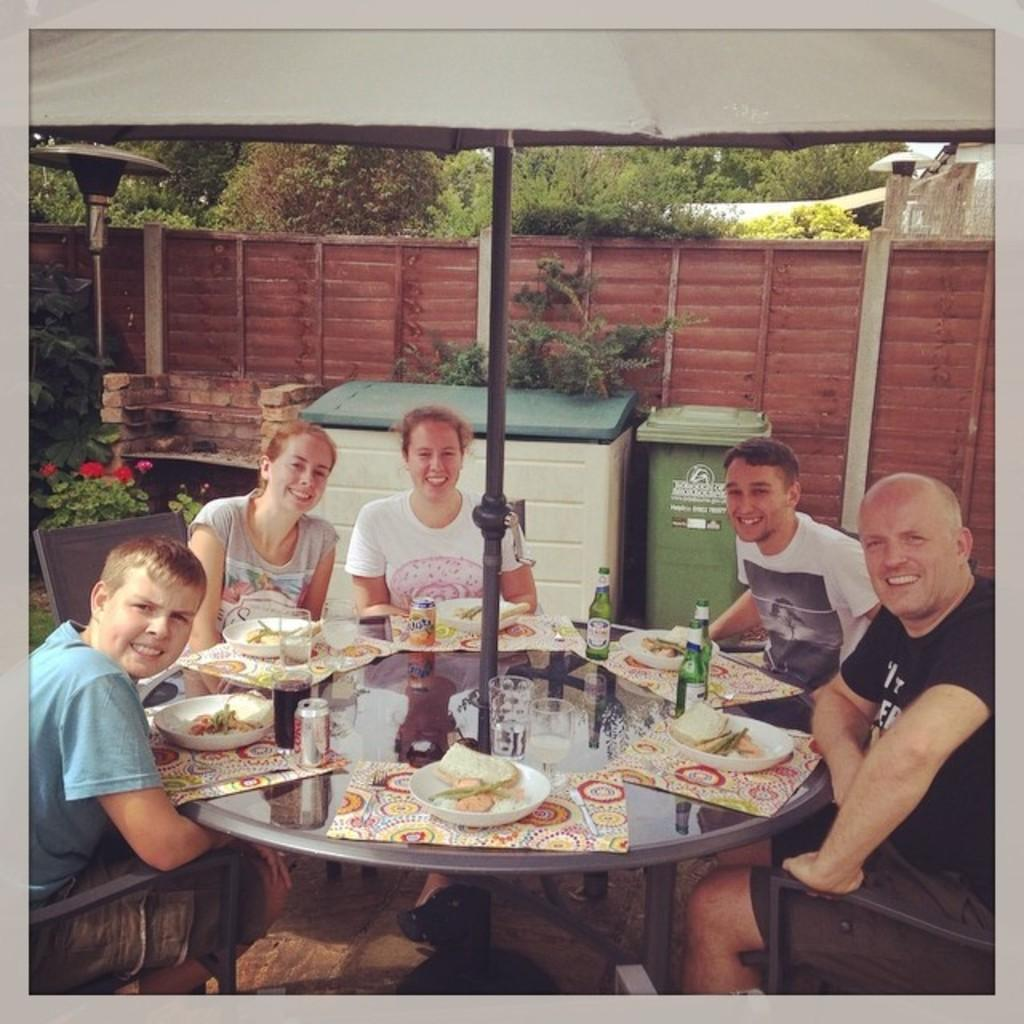What is happening with the group of people in the image? The people in the image are sitting on chairs and laughing. What is located in front of the group? There is a table with food in front of the group. What is providing shade for the group? There is an umbrella above the group. What can be seen in the background of the image? Trees are visible in the background of the image. What nation is being celebrated in the image? There is no indication of a nation being celebrated in the image. Can you tell me when the baby was born from the image? There is no baby or birth-related information present in the image. 